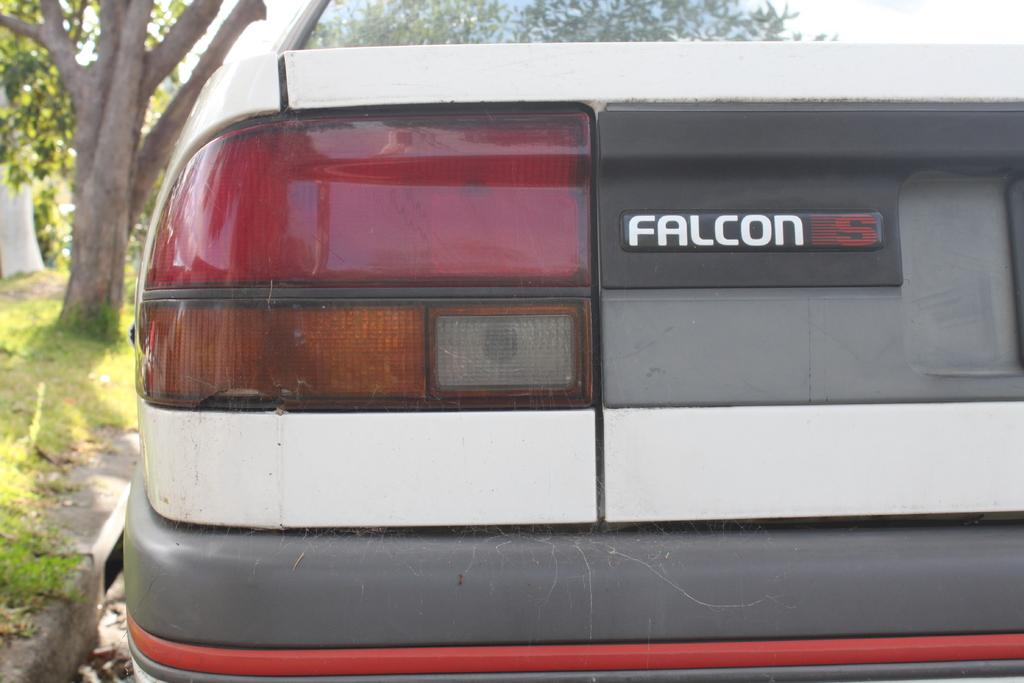What is the main subject of the image? There is a car in the image. How is the car positioned in the image? The car is viewed from the back side. What can be seen on the car? Car lights are visible, and there is text on the car. What type of vegetation is on the left side of the image? There is a tree and grass on the left side of the image. What type of protest is happening in the image? There is no protest present in the image; it features a car viewed from the back side. What does the car smell like in the image? The image does not convey any information about the car's smell. 